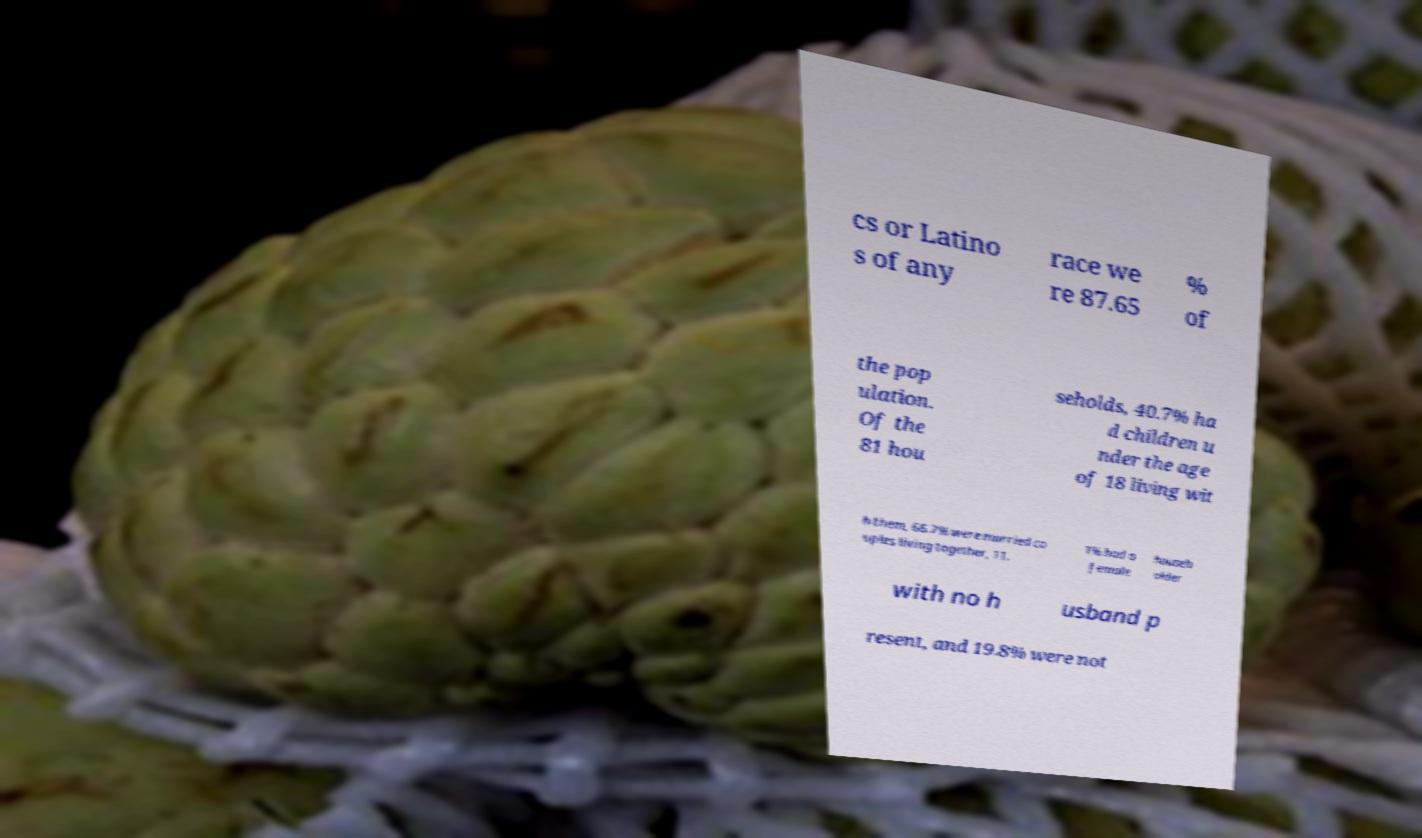What messages or text are displayed in this image? I need them in a readable, typed format. cs or Latino s of any race we re 87.65 % of the pop ulation. Of the 81 hou seholds, 40.7% ha d children u nder the age of 18 living wit h them, 66.7% were married co uples living together, 11. 1% had a female househ older with no h usband p resent, and 19.8% were not 